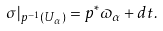Convert formula to latex. <formula><loc_0><loc_0><loc_500><loc_500>\sigma | _ { p ^ { - 1 } ( U _ { \alpha } ) } = p ^ { * } \varpi _ { \alpha } + d t .</formula> 